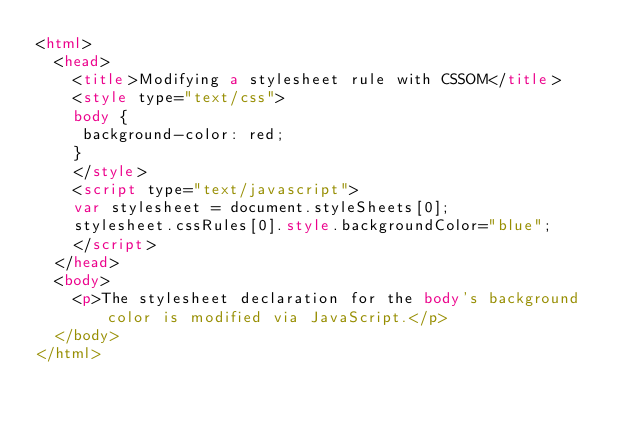Convert code to text. <code><loc_0><loc_0><loc_500><loc_500><_HTML_><html>
  <head>
    <title>Modifying a stylesheet rule with CSSOM</title>
    <style type="text/css">
    body {
     background-color: red;
    }
    </style>
    <script type="text/javascript">
    var stylesheet = document.styleSheets[0];
    stylesheet.cssRules[0].style.backgroundColor="blue";
    </script>
  </head>
  <body>
    <p>The stylesheet declaration for the body's background color is modified via JavaScript.</p>
  </body>
</html>
</code> 